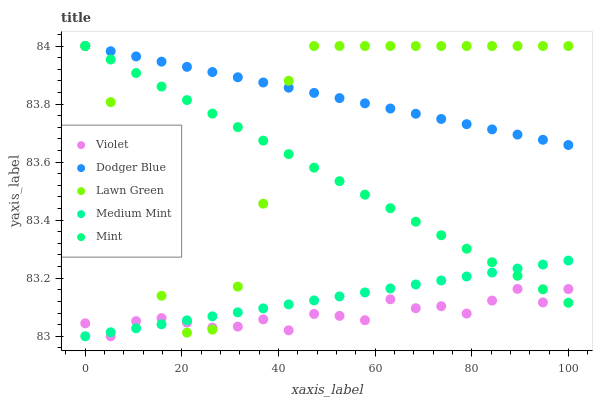Does Violet have the minimum area under the curve?
Answer yes or no. Yes. Does Dodger Blue have the maximum area under the curve?
Answer yes or no. Yes. Does Lawn Green have the minimum area under the curve?
Answer yes or no. No. Does Lawn Green have the maximum area under the curve?
Answer yes or no. No. Is Mint the smoothest?
Answer yes or no. Yes. Is Lawn Green the roughest?
Answer yes or no. Yes. Is Dodger Blue the smoothest?
Answer yes or no. No. Is Dodger Blue the roughest?
Answer yes or no. No. Does Medium Mint have the lowest value?
Answer yes or no. Yes. Does Lawn Green have the lowest value?
Answer yes or no. No. Does Mint have the highest value?
Answer yes or no. Yes. Does Violet have the highest value?
Answer yes or no. No. Is Violet less than Dodger Blue?
Answer yes or no. Yes. Is Dodger Blue greater than Medium Mint?
Answer yes or no. Yes. Does Dodger Blue intersect Lawn Green?
Answer yes or no. Yes. Is Dodger Blue less than Lawn Green?
Answer yes or no. No. Is Dodger Blue greater than Lawn Green?
Answer yes or no. No. Does Violet intersect Dodger Blue?
Answer yes or no. No. 